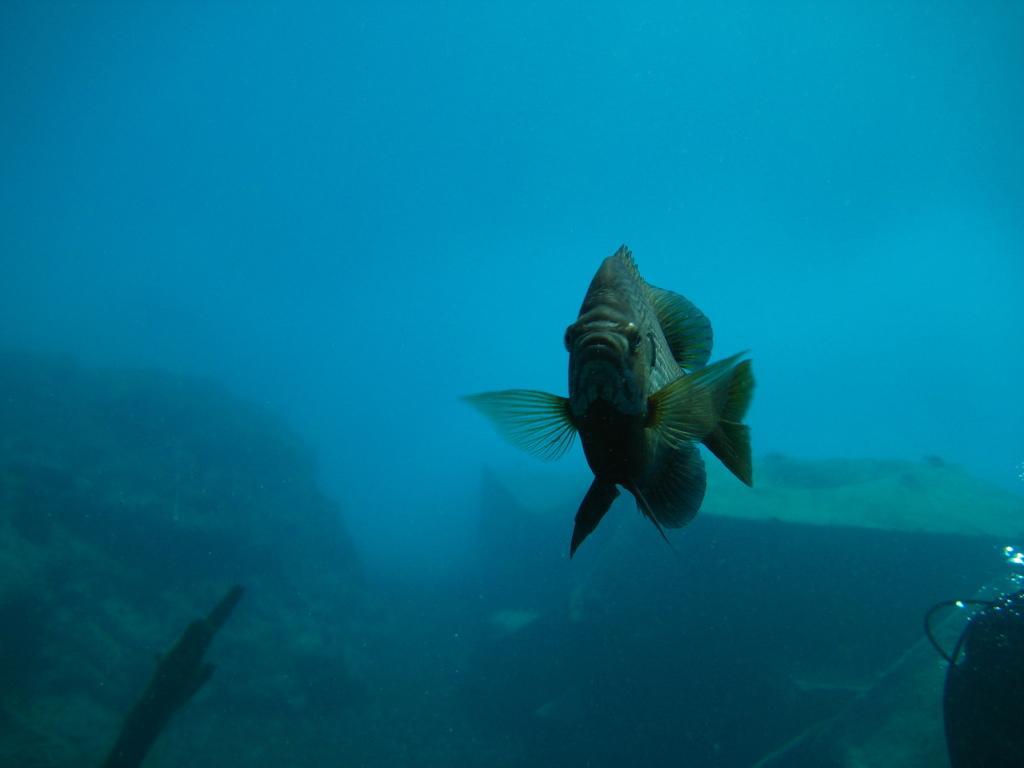Can you describe this image briefly? In the picture we can see a deep in the water with rocks and a fish with wings and tail. 